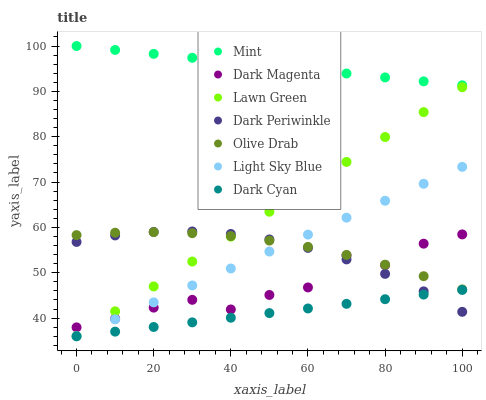Does Dark Cyan have the minimum area under the curve?
Answer yes or no. Yes. Does Mint have the maximum area under the curve?
Answer yes or no. Yes. Does Dark Magenta have the minimum area under the curve?
Answer yes or no. No. Does Dark Magenta have the maximum area under the curve?
Answer yes or no. No. Is Dark Cyan the smoothest?
Answer yes or no. Yes. Is Dark Magenta the roughest?
Answer yes or no. Yes. Is Light Sky Blue the smoothest?
Answer yes or no. No. Is Light Sky Blue the roughest?
Answer yes or no. No. Does Lawn Green have the lowest value?
Answer yes or no. Yes. Does Dark Magenta have the lowest value?
Answer yes or no. No. Does Mint have the highest value?
Answer yes or no. Yes. Does Dark Magenta have the highest value?
Answer yes or no. No. Is Lawn Green less than Mint?
Answer yes or no. Yes. Is Mint greater than Dark Periwinkle?
Answer yes or no. Yes. Does Olive Drab intersect Dark Periwinkle?
Answer yes or no. Yes. Is Olive Drab less than Dark Periwinkle?
Answer yes or no. No. Is Olive Drab greater than Dark Periwinkle?
Answer yes or no. No. Does Lawn Green intersect Mint?
Answer yes or no. No. 